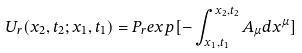Convert formula to latex. <formula><loc_0><loc_0><loc_500><loc_500>U _ { r } ( x _ { 2 } , t _ { 2 } ; x _ { 1 } , t _ { 1 } ) = P _ { r } e x p [ - \int _ { x _ { 1 } , t _ { 1 } } ^ { x _ { 2 } , t _ { 2 } } A _ { \mu } d x ^ { \mu } ]</formula> 